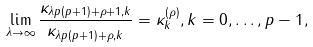<formula> <loc_0><loc_0><loc_500><loc_500>\lim _ { \lambda \to \infty } \frac { \kappa _ { \lambda p ( p + 1 ) + \rho + 1 , k } } { \kappa _ { \lambda p ( p + 1 ) + \rho , k } } = \kappa _ { k } ^ { ( \rho ) } , k = 0 , \dots , p - 1 ,</formula> 